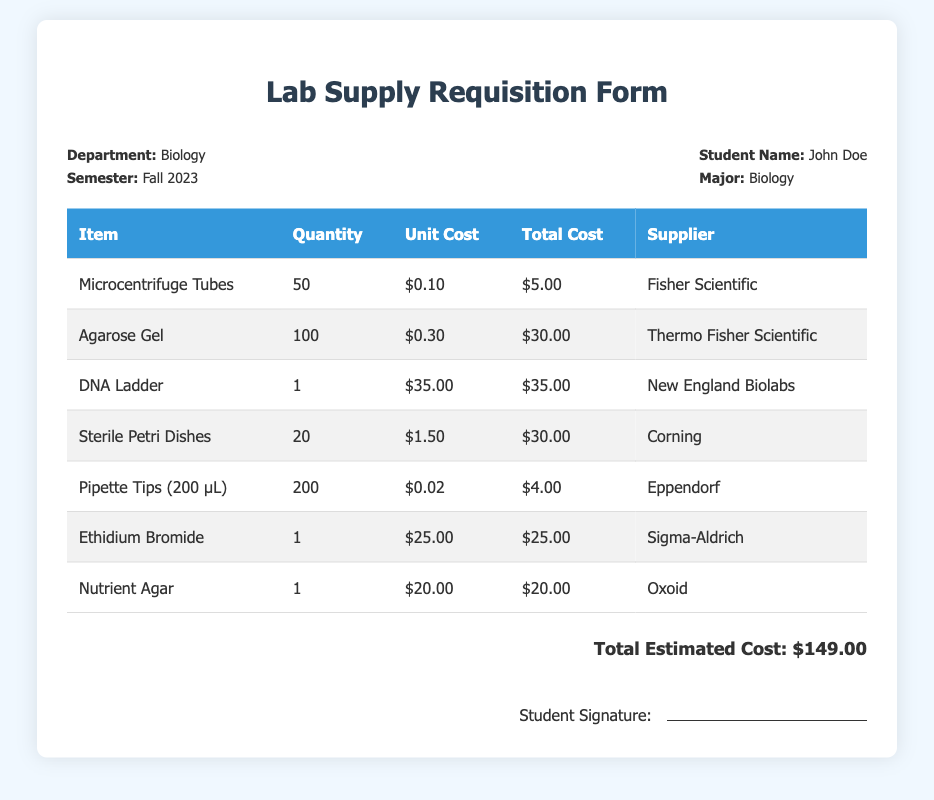What is the total estimated cost? The total estimated cost is explicitly stated at the bottom of the document after summing all individual total costs.
Answer: $149.00 Who is the student making the requisition? The student's name is specified near the top of the document under the header information section.
Answer: John Doe What is the quantity of Microcentrifuge Tubes requested? The quantity requested is listed in the table under the respective item.
Answer: 50 Which supplier provides the DNA Ladder? The supplier is indicated in the table beside the corresponding item entry.
Answer: New England Biolabs What is the unit cost of Ethidium Bromide? The unit cost is detailed next to the item in the table, allowing for easy reference.
Answer: $25.00 How many types of items are listed in the requisition? The number of unique items can be counted from the rows in the table, which represents each requested material.
Answer: 7 Which item has the highest total cost? The total costs are presented in the table, and the item with the highest total can be identified by comparing the values.
Answer: DNA Ladder What is the department for this requisition? The department information is outlined in the header section of the document.
Answer: Biology What item has the lowest unit cost? The unit costs of the items can be reviewed in the table to find the lowest price point.
Answer: Microcentrifuge Tubes 